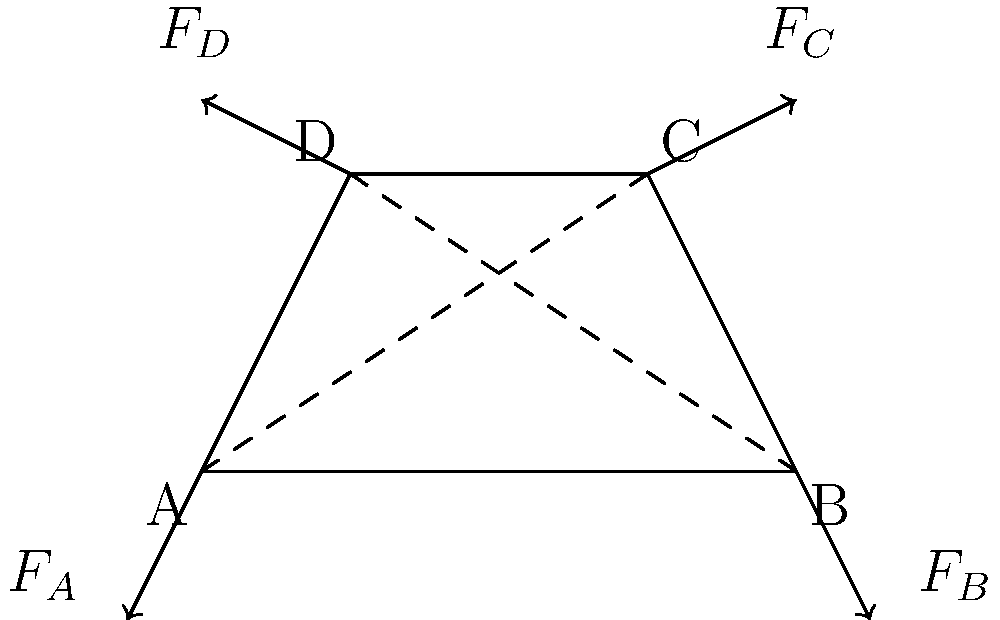In the four-bar linkage mechanism shown, analyze the force diagram and determine which of the following statements is correct regarding the forces acting on the links when the mechanism is in static equilibrium:

a) $F_A + F_B = F_C + F_D$
b) $F_A + F_D = F_B + F_C$
c) $F_A + F_C = F_B + F_D$
d) The sum of all forces must be zero

Explain your reasoning, considering the principles of static equilibrium and the geometry of the linkage. To analyze the force diagram of the four-bar linkage mechanism, we need to consider the principles of static equilibrium and the geometry of the linkage. Let's approach this step-by-step:

1. Static Equilibrium: For a system to be in static equilibrium, two conditions must be met:
   a) The sum of all forces must be zero: $\sum \vec{F} = 0$
   b) The sum of all moments about any point must be zero: $\sum M = 0$

2. Force Analysis:
   - $F_A$ and $F_B$ are the reaction forces at the fixed pivot points A and B.
   - $F_C$ and $F_D$ are the forces acting on the moving joints C and D.

3. Geometry Consideration:
   - The linkage forms a closed loop, meaning the forces must balance in both horizontal and vertical directions.

4. Force Balance:
   - For horizontal equilibrium: $F_{Ax} + F_{Bx} + F_{Cx} + F_{Dx} = 0$
   - For vertical equilibrium: $F_{Ay} + F_{By} + F_{Cy} + F_{Dy} = 0$

5. Moment Balance:
   - Taking moments about any point (e.g., point A) should result in zero net moment.

6. Evaluation of Options:
   a) $F_A + F_B = F_C + F_D$ is incorrect because it doesn't consider the vector nature of forces.
   b) $F_A + F_D = F_B + F_C$ is incorrect for the same reason.
   c) $F_A + F_C = F_B + F_D$ is also incorrect as it arbitrarily pairs forces.
   d) The sum of all forces must be zero is correct, as it aligns with the first condition of static equilibrium.

Therefore, the correct statement is option d) The sum of all forces must be zero. This satisfies the fundamental principle of static equilibrium and accounts for the vector nature of the forces in the linkage mechanism.
Answer: d) The sum of all forces must be zero 